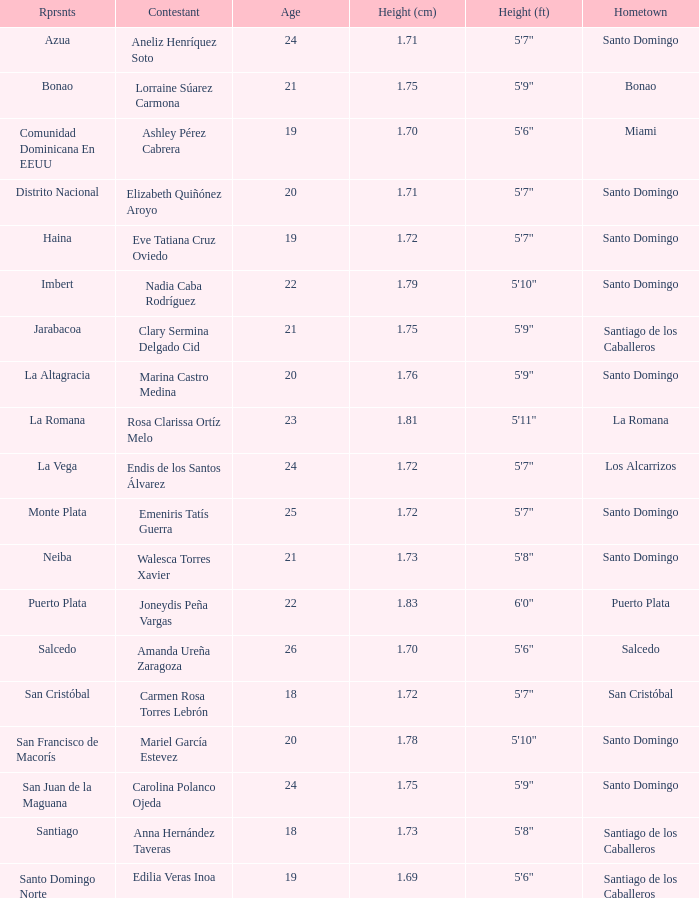Name the represents for 1.76 cm La Altagracia. 